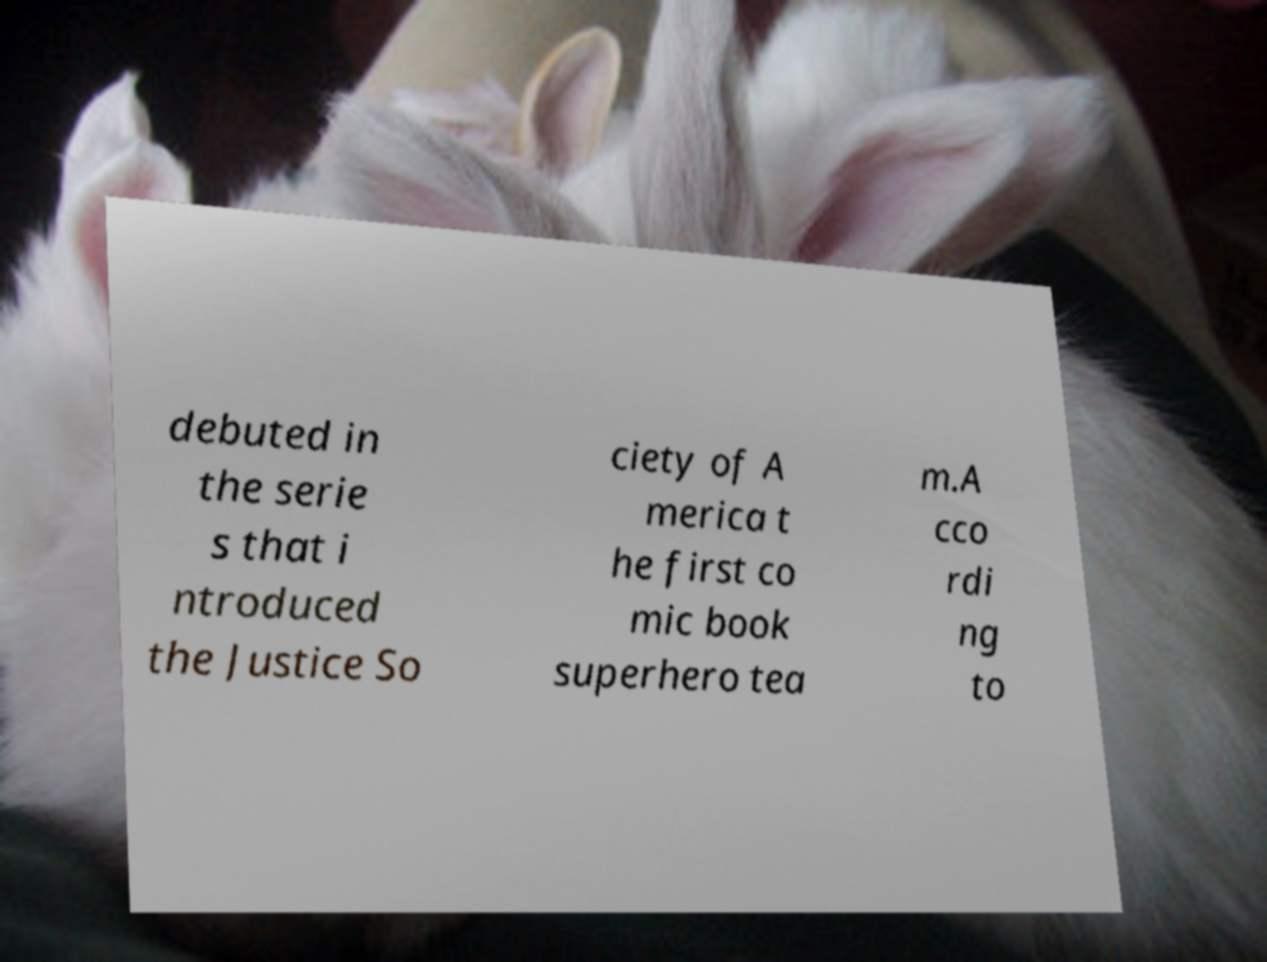There's text embedded in this image that I need extracted. Can you transcribe it verbatim? debuted in the serie s that i ntroduced the Justice So ciety of A merica t he first co mic book superhero tea m.A cco rdi ng to 